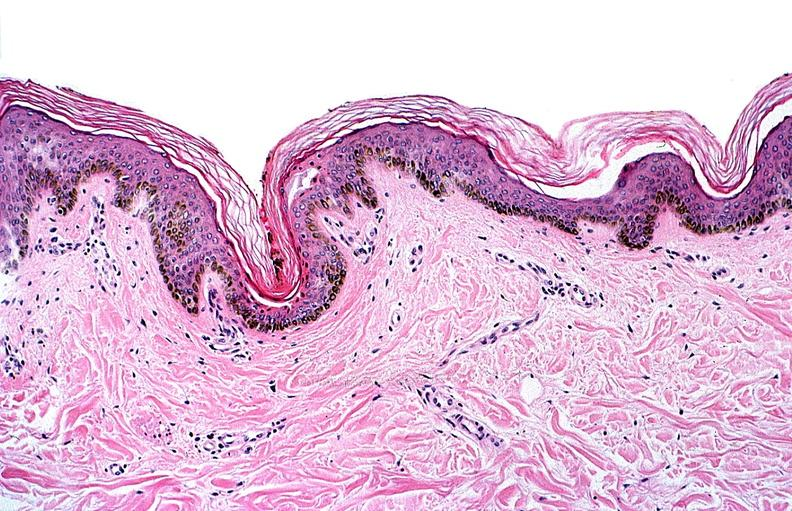does this image show thermal burned skin?
Answer the question using a single word or phrase. Yes 